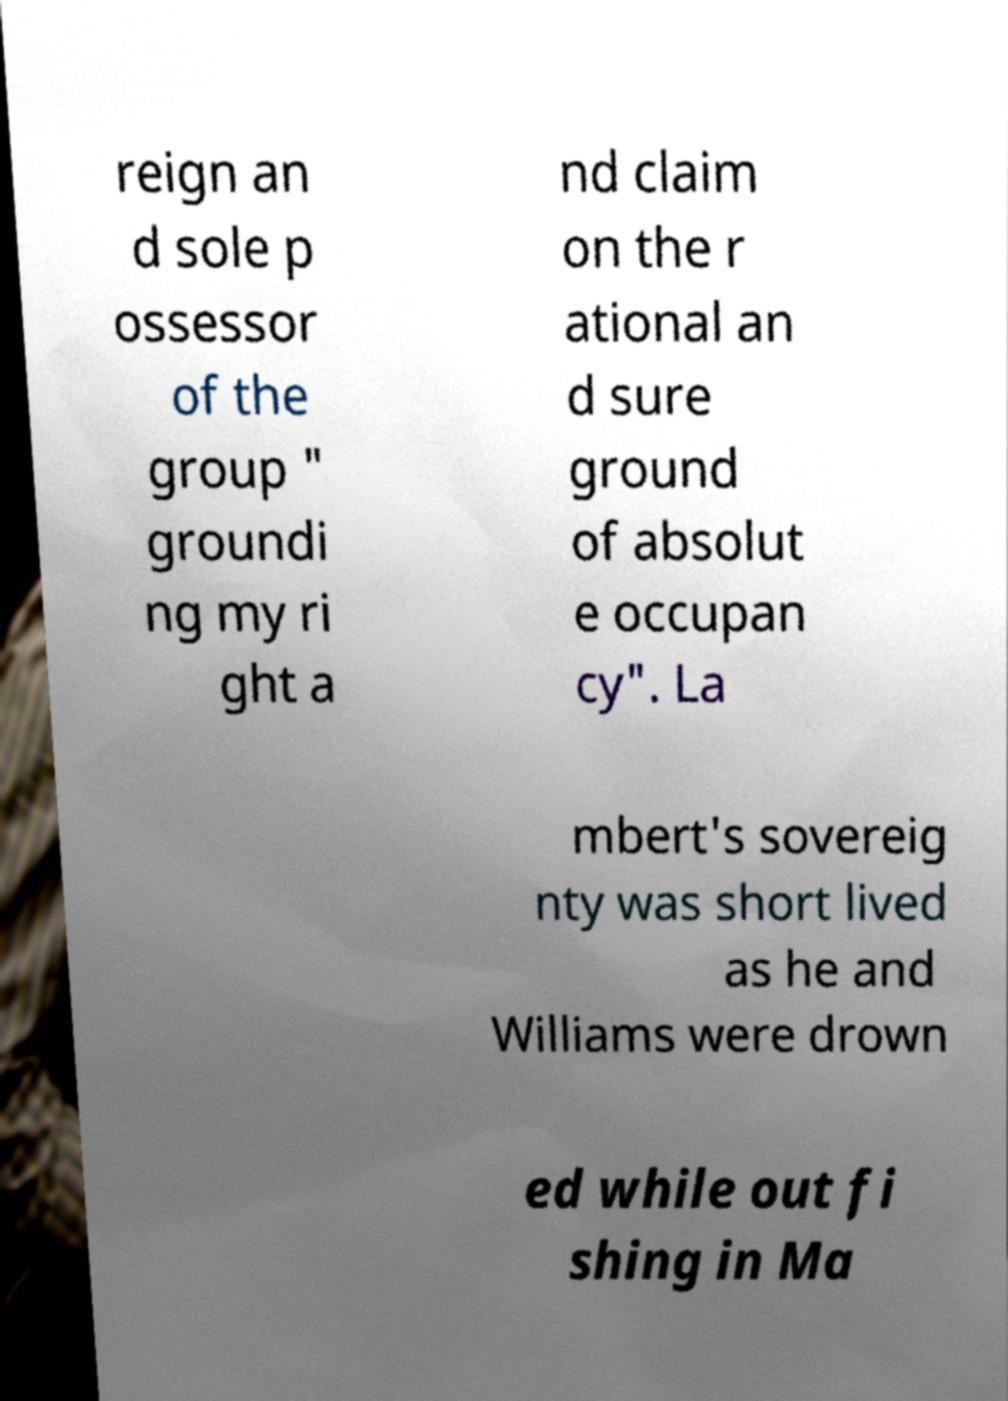There's text embedded in this image that I need extracted. Can you transcribe it verbatim? reign an d sole p ossessor of the group " groundi ng my ri ght a nd claim on the r ational an d sure ground of absolut e occupan cy". La mbert's sovereig nty was short lived as he and Williams were drown ed while out fi shing in Ma 